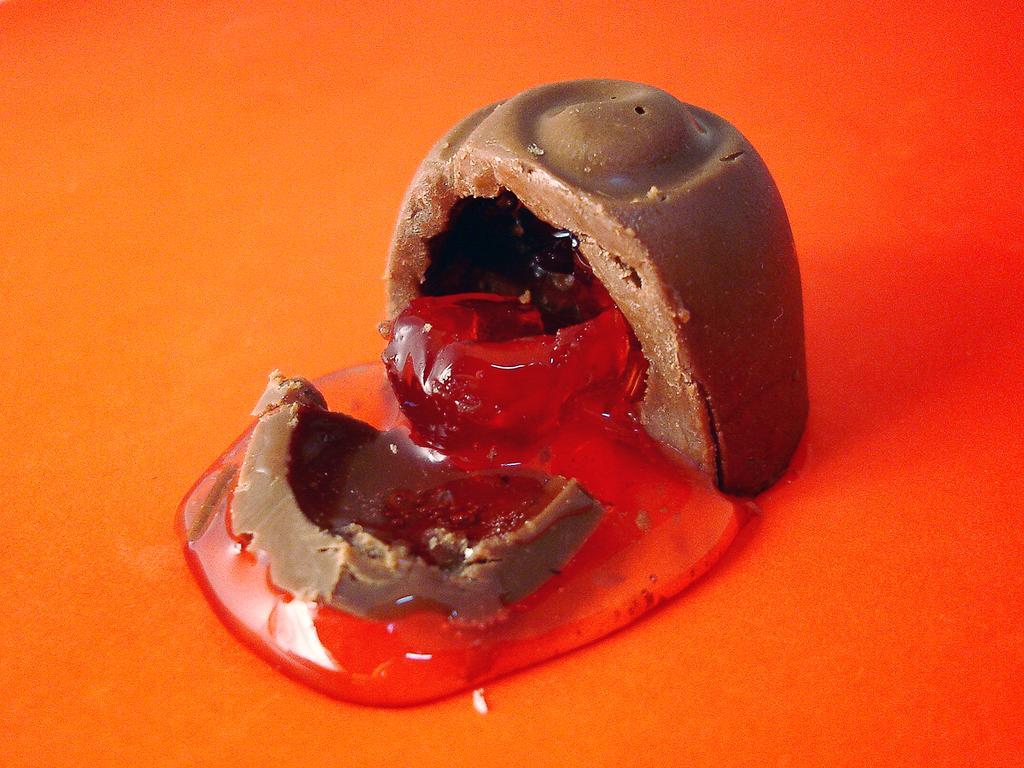Can you describe this image briefly? In this image in the center there is one chocolate from the chocolate there is some substance coming out, at the bottom there is orange color. 